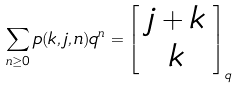<formula> <loc_0><loc_0><loc_500><loc_500>\sum _ { n \geq 0 } p ( k , j , n ) q ^ { n } = \left [ \begin{array} { c } j + k \\ k \end{array} \right ] _ { q }</formula> 